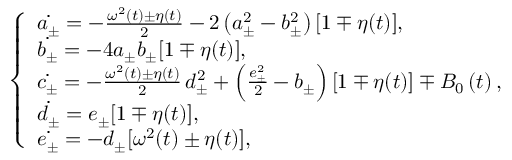Convert formula to latex. <formula><loc_0><loc_0><loc_500><loc_500>\left \{ \begin{array} { l l } { \dot { a _ { \pm } } = - \frac { \omega ^ { 2 } \left ( t \right ) \pm \eta ( t ) } { 2 } - 2 \left ( a _ { \pm } ^ { 2 } - b _ { \pm } ^ { 2 } \right ) [ 1 \mp \eta ( t ) ] , } \\ { \dot { b _ { \pm } } = - 4 a _ { \pm } b _ { \pm } [ 1 \mp \eta ( t ) ] , } \\ { \dot { c _ { \pm } } = - \frac { \omega ^ { 2 } \left ( t \right ) \pm \eta ( t ) } { 2 } \, d _ { \pm } ^ { 2 } + \left ( \frac { e _ { \pm } ^ { 2 } } { 2 } - b _ { \pm } \right ) \left [ 1 \mp \eta ( t ) \right ] \mp B _ { 0 } \left ( t \right ) , } \\ { \dot { d _ { \pm } } = e _ { \pm } [ 1 \mp \eta ( t ) ] , } \\ { \dot { e _ { \pm } } = - d _ { \pm } [ \omega ^ { 2 } ( t ) \pm \eta ( t ) ] , } \end{array}</formula> 